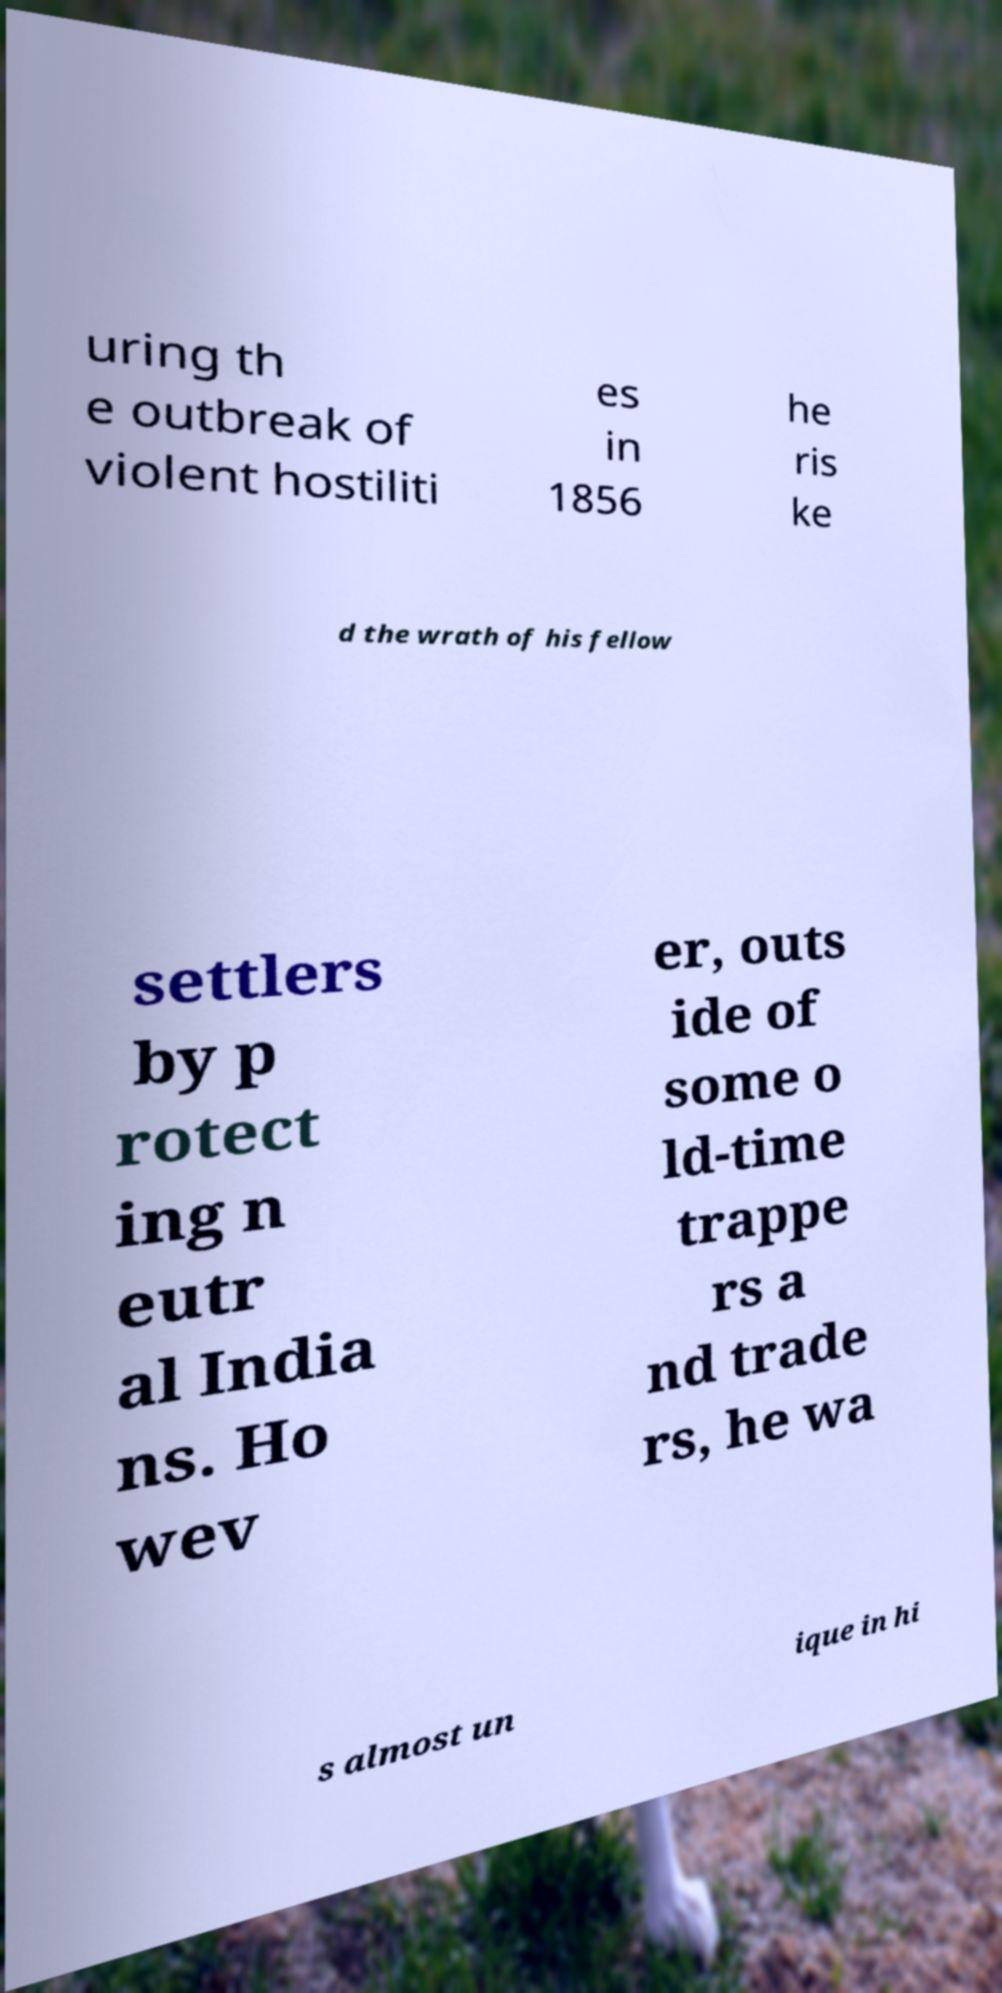Can you read and provide the text displayed in the image?This photo seems to have some interesting text. Can you extract and type it out for me? uring th e outbreak of violent hostiliti es in 1856 he ris ke d the wrath of his fellow settlers by p rotect ing n eutr al India ns. Ho wev er, outs ide of some o ld-time trappe rs a nd trade rs, he wa s almost un ique in hi 